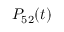Convert formula to latex. <formula><loc_0><loc_0><loc_500><loc_500>P _ { 5 2 } ( t )</formula> 